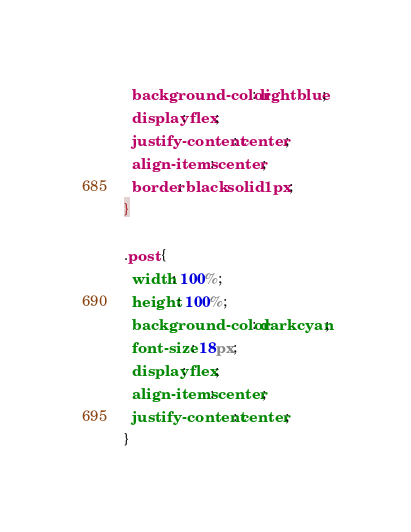Convert code to text. <code><loc_0><loc_0><loc_500><loc_500><_CSS_>  background-color: lightblue;
  display: flex;
  justify-content: center;
  align-items: center;
  border: black solid 1px;
}

.post {
  width: 100%;
  height: 100%;
  background-color: darkcyan;
  font-size: 18px;
  display: flex;
  align-items: center;
  justify-content: center;
}
</code> 